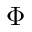Convert formula to latex. <formula><loc_0><loc_0><loc_500><loc_500>\Phi</formula> 